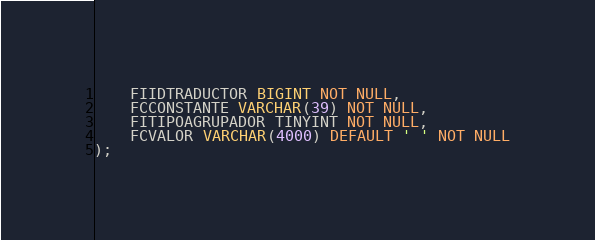<code> <loc_0><loc_0><loc_500><loc_500><_SQL_>    FIIDTRADUCTOR BIGINT NOT NULL,
    FCCONSTANTE VARCHAR(39) NOT NULL,
    FITIPOAGRUPADOR TINYINT NOT NULL,
    FCVALOR VARCHAR(4000) DEFAULT ' ' NOT NULL
);     </code> 